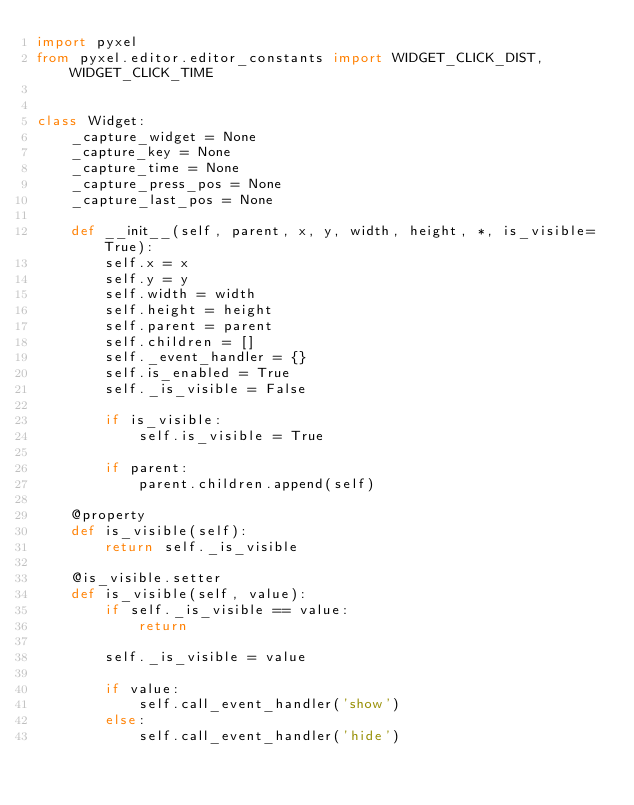Convert code to text. <code><loc_0><loc_0><loc_500><loc_500><_Python_>import pyxel
from pyxel.editor.editor_constants import WIDGET_CLICK_DIST, WIDGET_CLICK_TIME


class Widget:
    _capture_widget = None
    _capture_key = None
    _capture_time = None
    _capture_press_pos = None
    _capture_last_pos = None

    def __init__(self, parent, x, y, width, height, *, is_visible=True):
        self.x = x
        self.y = y
        self.width = width
        self.height = height
        self.parent = parent
        self.children = []
        self._event_handler = {}
        self.is_enabled = True
        self._is_visible = False

        if is_visible:
            self.is_visible = True

        if parent:
            parent.children.append(self)

    @property
    def is_visible(self):
        return self._is_visible

    @is_visible.setter
    def is_visible(self, value):
        if self._is_visible == value:
            return

        self._is_visible = value

        if value:
            self.call_event_handler('show')
        else:
            self.call_event_handler('hide')
</code> 